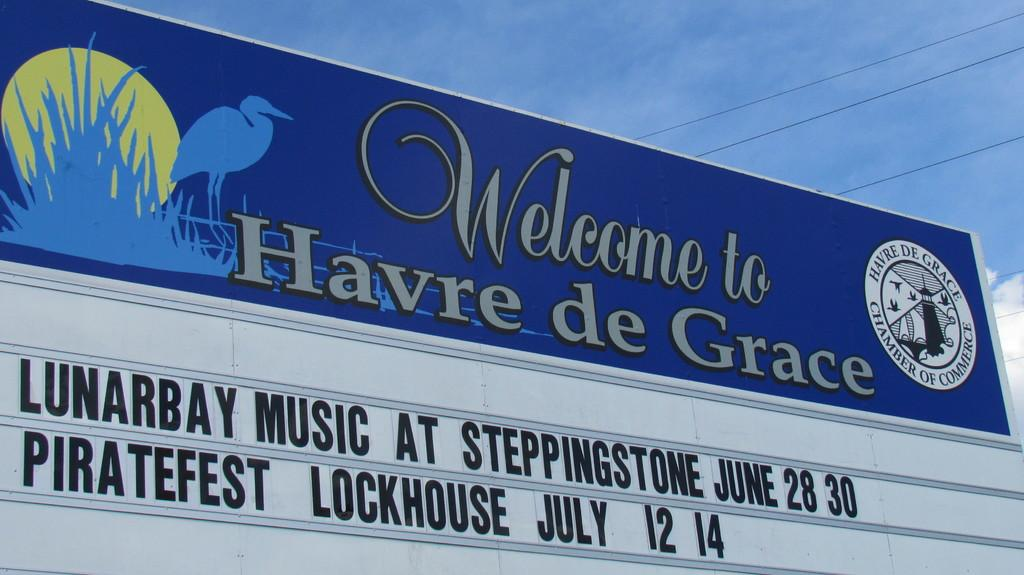<image>
Describe the image concisely. a sign that says Welcome to Havre De  Grace 